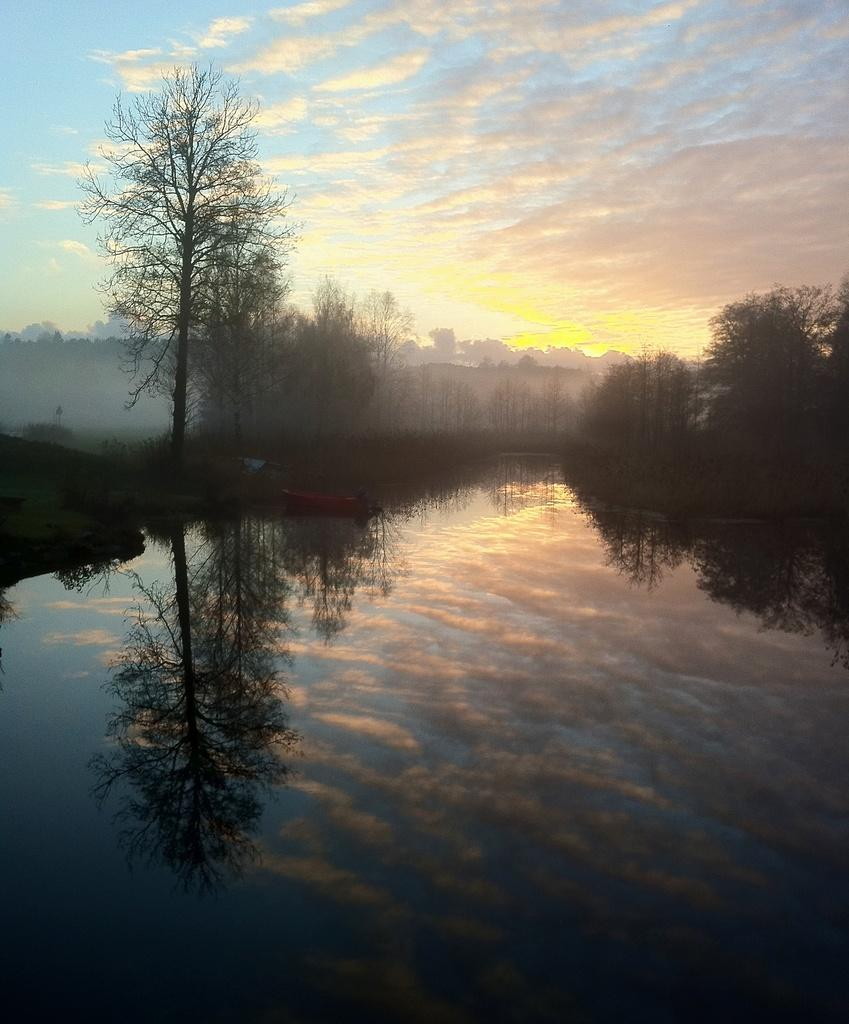What is present in the front of the image? There is water in the front of the image. What can be seen in the background of the image? There are trees in the background of the image. What is visible in the sky in the image? Clouds are visible in the sky. Can you tell me how many bees are sitting on the cast in the image? There are no bees or casts present in the image. What type of scale is used to measure the weight of the trees in the image? There is no scale present in the image, and the trees are not being measured for weight. 